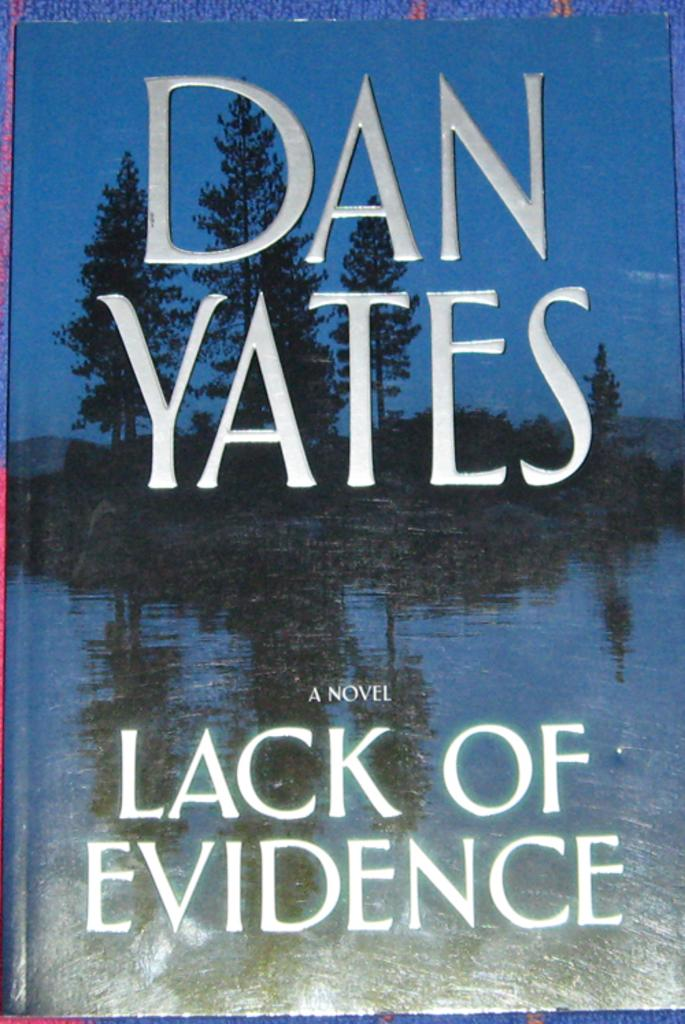<image>
Give a short and clear explanation of the subsequent image. A book by a Dan Yates called Lack of Evidence. 